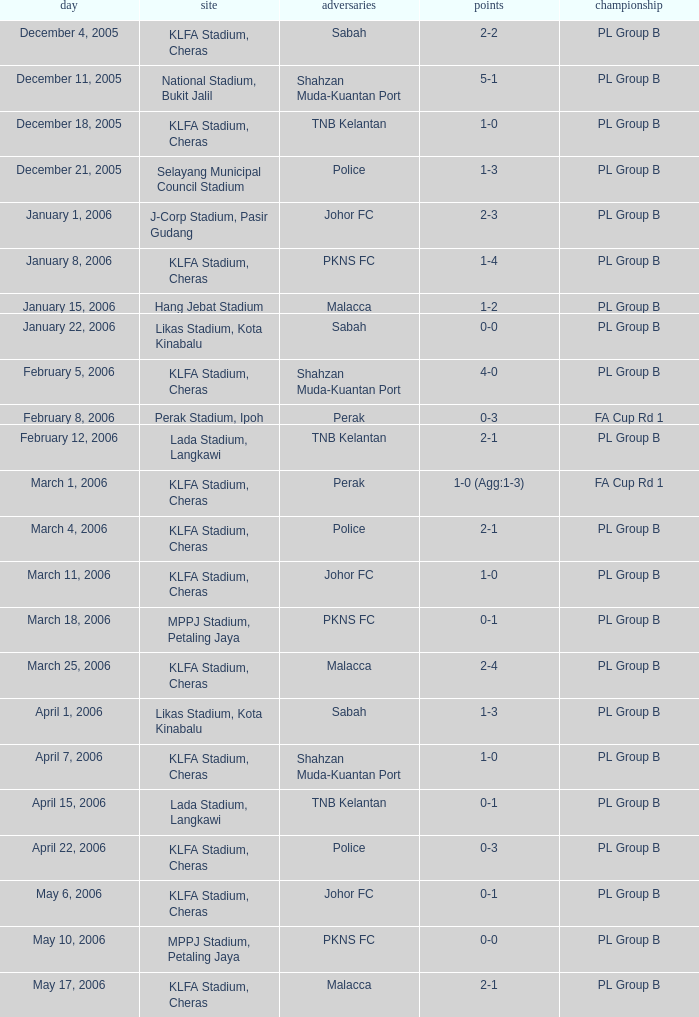Who competed on may 6, 2006? Johor FC. 